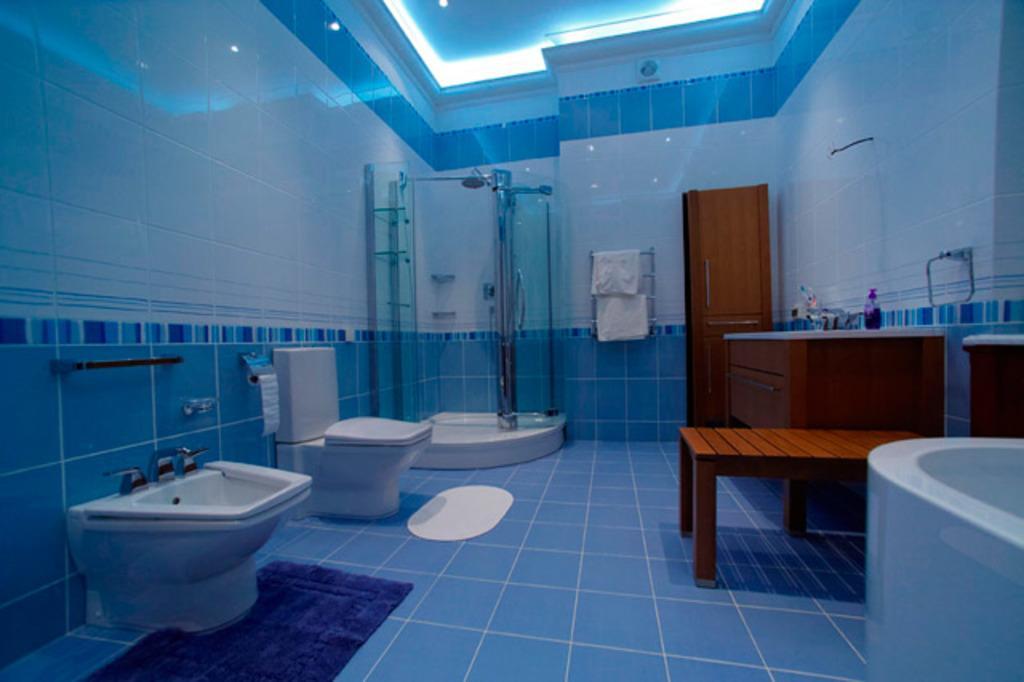In one or two sentences, can you explain what this image depicts? This is a picture of the inside of the washroom. In this image on the right side there is one table beside that table one door is there, and on the left side there are two toilets. And in the middle of the image there are two clothes and on the top of the image there is one wall and one floor and on the floor there is one carpet and doormat is there and in the background there is one glass door on the bottom of the right corner there is one bathtub. 